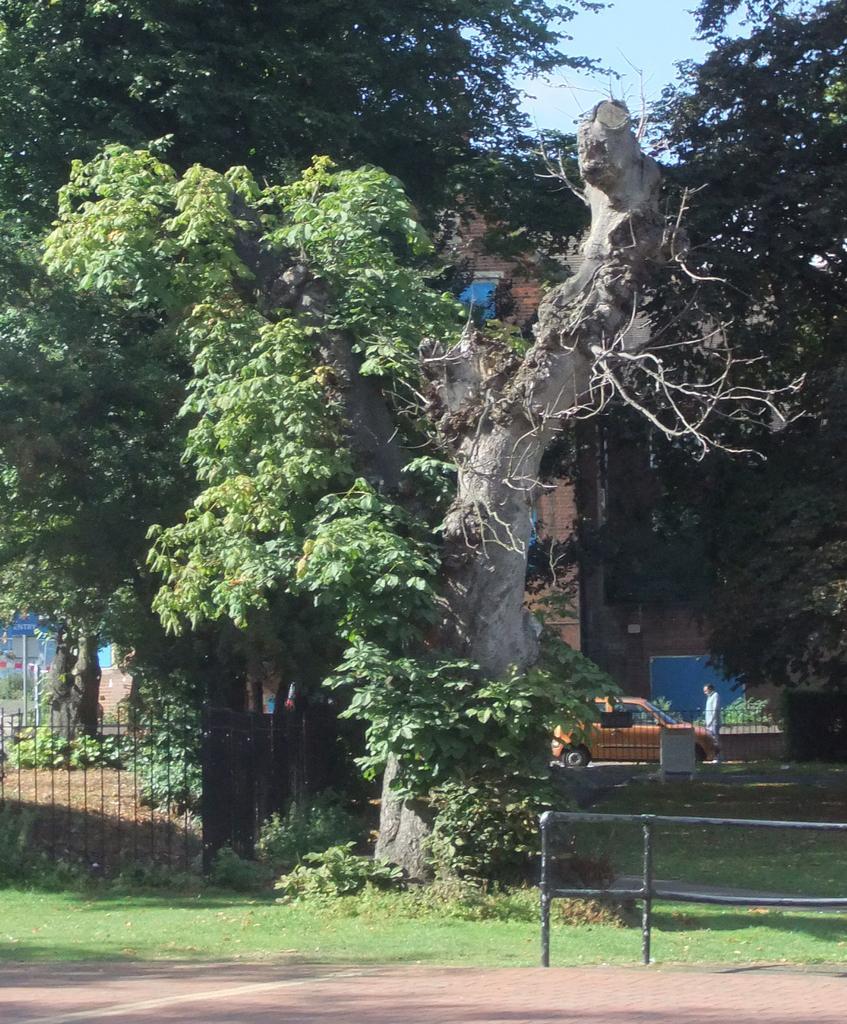How would you summarize this image in a sentence or two? In this image there is a tree on the grass, behind that there is a fence, car and building. 